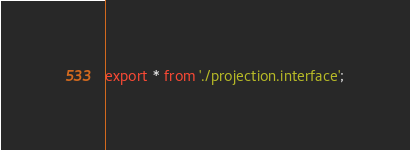<code> <loc_0><loc_0><loc_500><loc_500><_TypeScript_>export * from './projection.interface';
</code> 